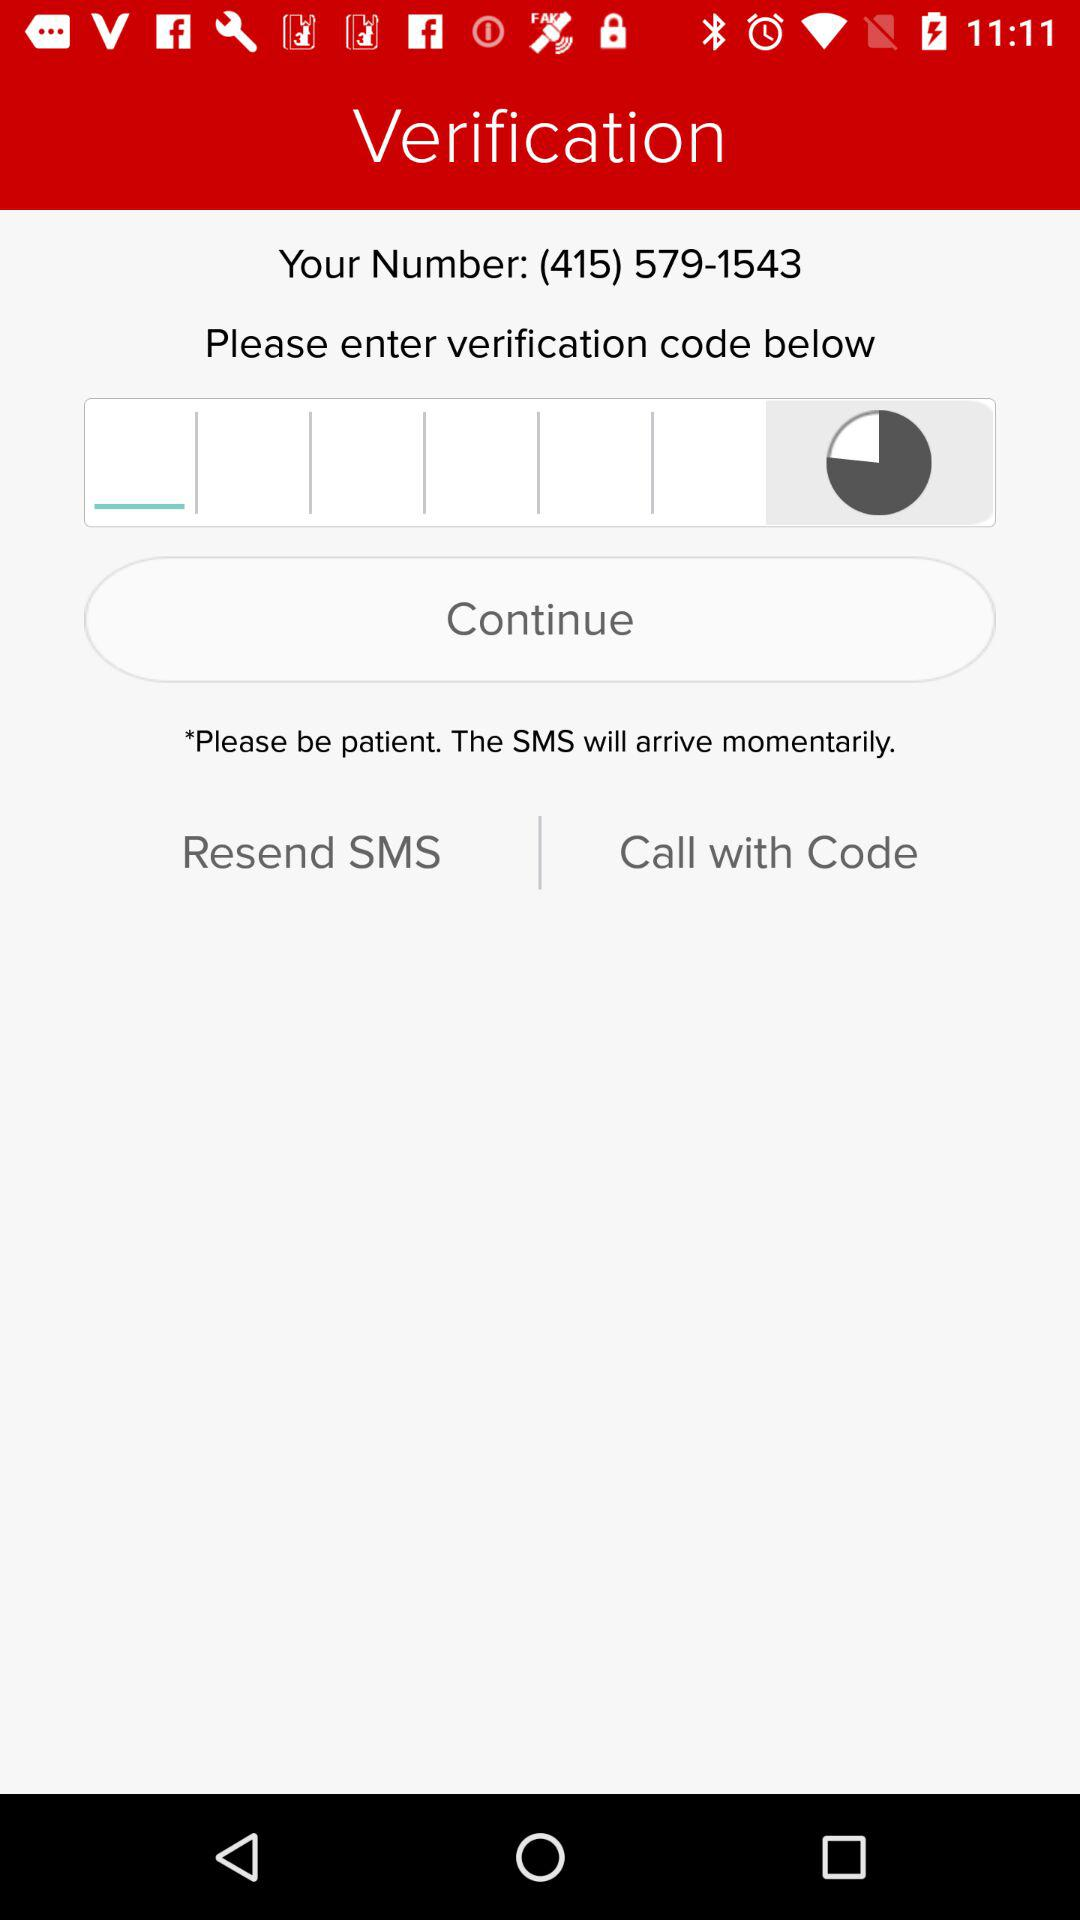What is the name of the company? The name of the company is "IDT Domestic Telecom, Inc.". 